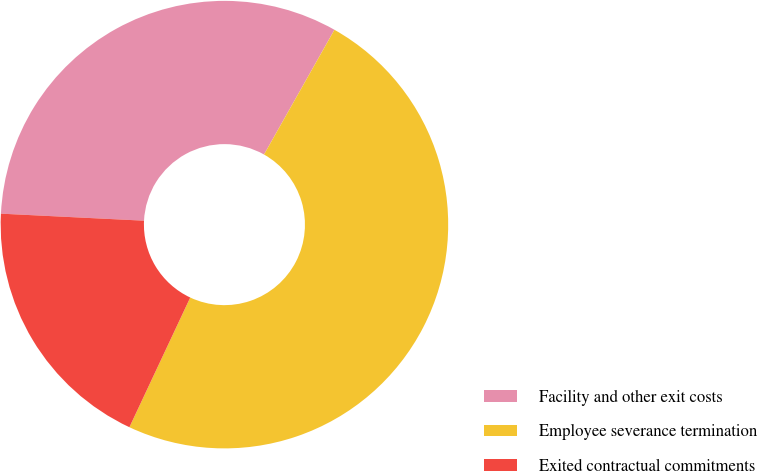Convert chart. <chart><loc_0><loc_0><loc_500><loc_500><pie_chart><fcel>Facility and other exit costs<fcel>Employee severance termination<fcel>Exited contractual commitments<nl><fcel>32.4%<fcel>48.8%<fcel>18.8%<nl></chart> 